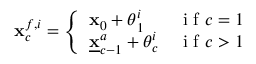<formula> <loc_0><loc_0><loc_500><loc_500>{ x } _ { c } ^ { f , i } = \left \{ \begin{array} { l l } { { x } _ { 0 } + { \theta } _ { 1 } ^ { i } } & { i f c = 1 } \\ { \underline { x } _ { c - 1 } ^ { a } + { \theta } _ { c } ^ { i } } & { i f c > 1 } \end{array}</formula> 